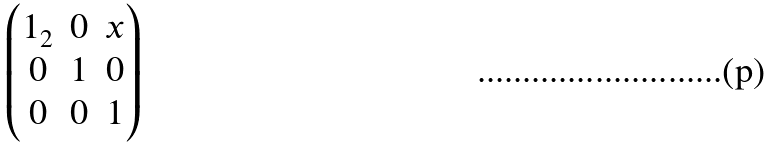<formula> <loc_0><loc_0><loc_500><loc_500>\begin{pmatrix} 1 _ { 2 } & 0 & x \\ 0 & 1 & 0 \\ 0 & 0 & 1 \end{pmatrix}</formula> 